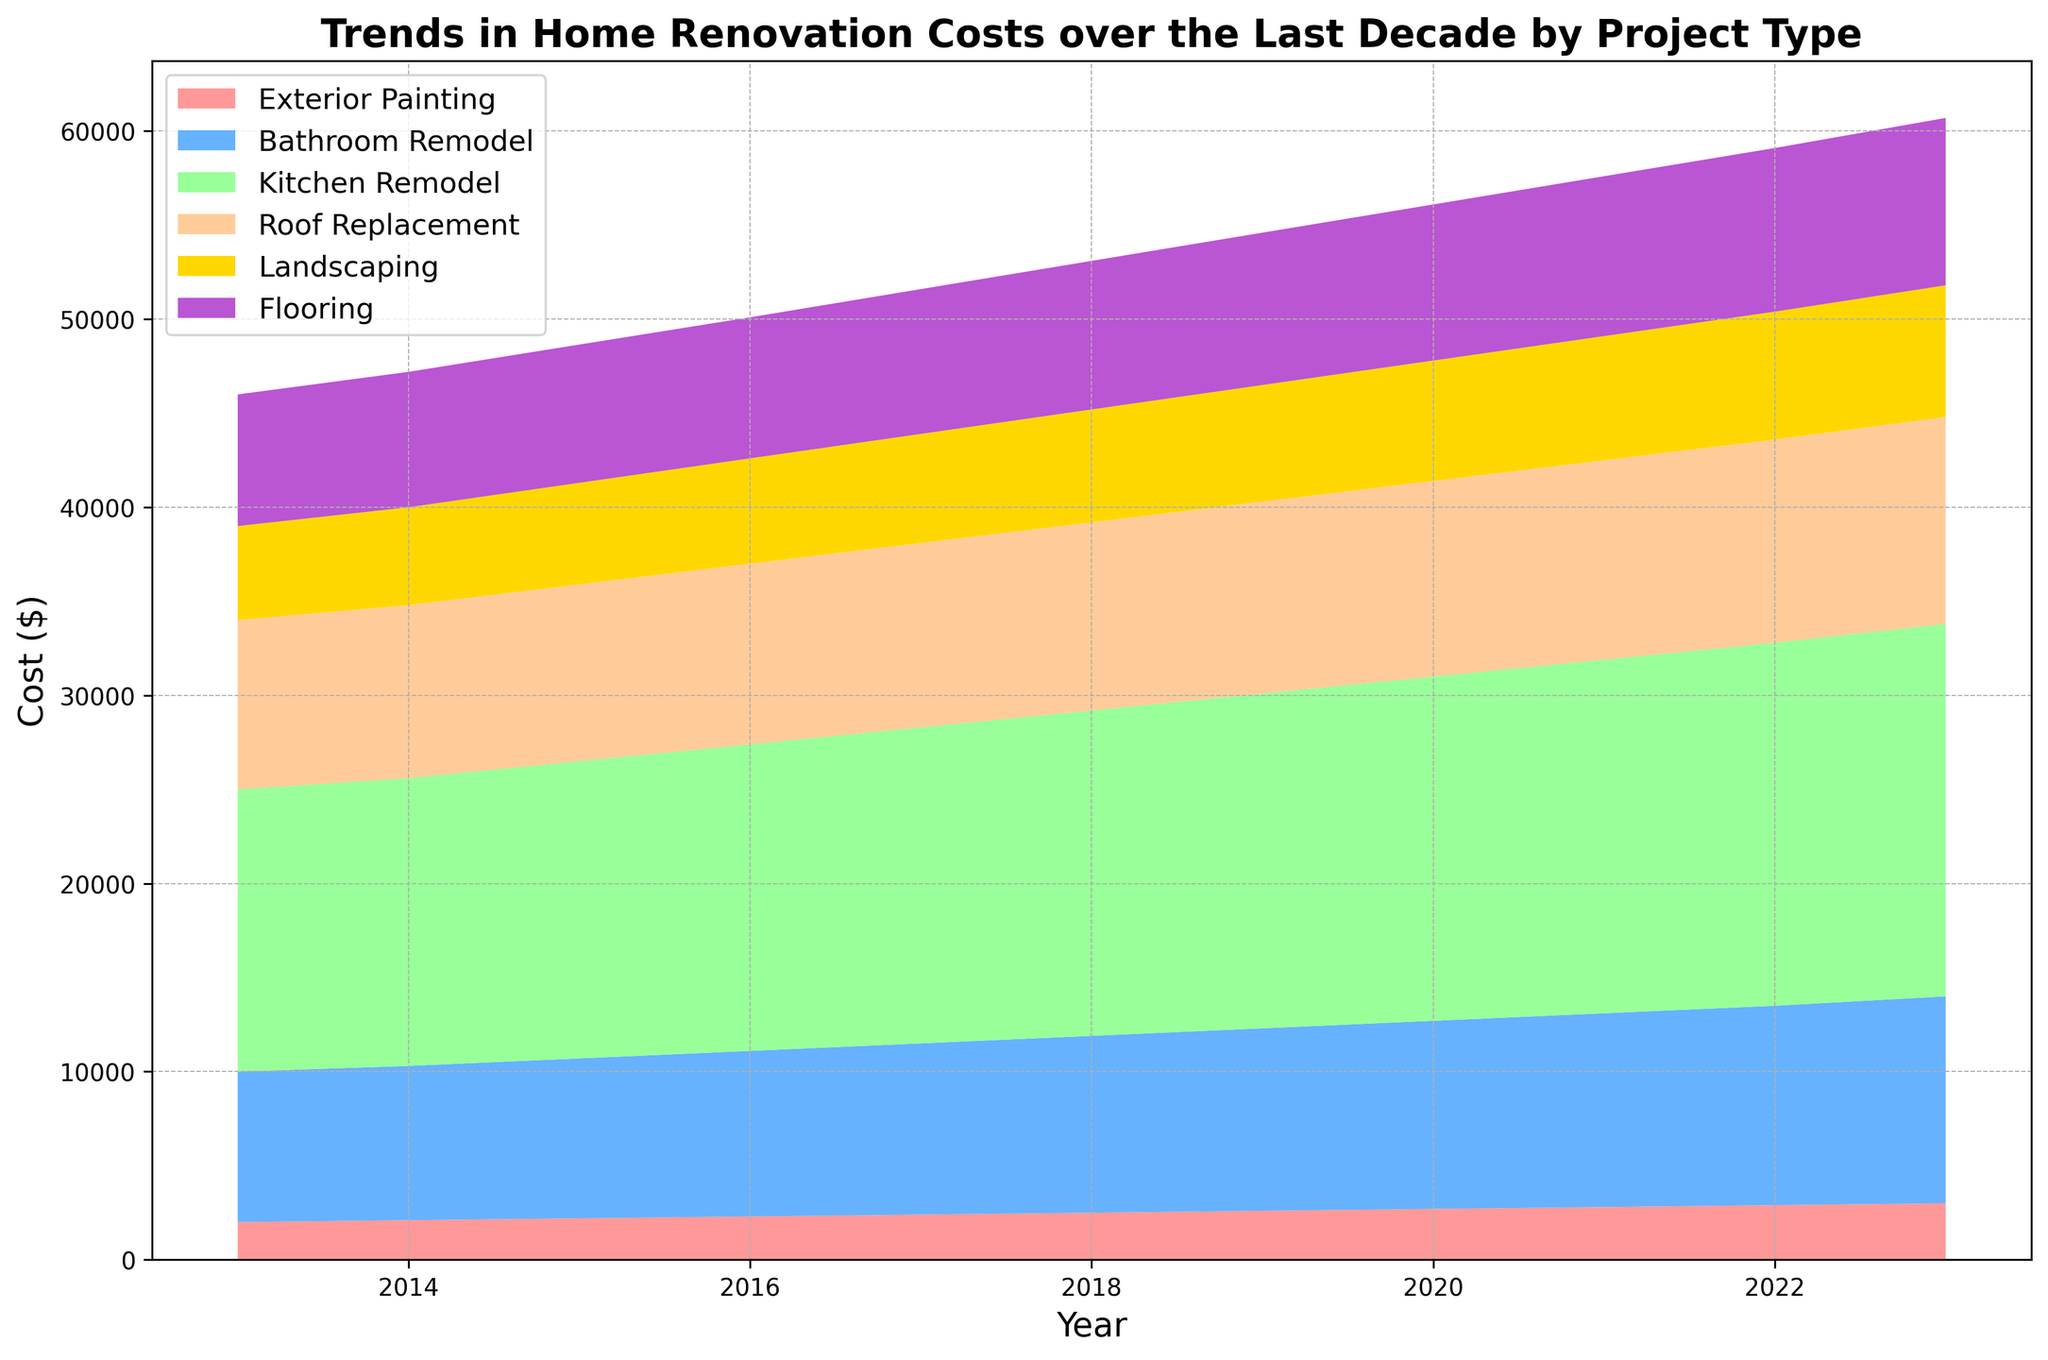What trend do you observe in the cost of exterior painting over the decade? The chart shows a steadily increasing trend in the cost of exterior painting from 2013 to 2023.
Answer: Increasing trend Which project type had the highest cost in 2023? In 2023, the highest cost is represented by the tallest area segment in the stack, which corresponds to the kitchen remodel.
Answer: Kitchen remodel How does the cost of a bathroom remodel compare to a roof replacement in 2020? In 2020, the height of the area segment for bathroom remodel is slightly lower than the segment for roof replacement, indicating its cost was lower.
Answer: Lower What is the total cost of kitchen remodeling from 2013 to 2023? To find the total cost, sum all kitchen remodel costs from 2013 to 2023: 15000 + 15300 + 15800 + 16300 + 16800 + 17300 + 17800 + 18300 + 18800 + 19300 + 19800 = 183400.
Answer: $183,400 By how much did the cost of flooring increase from 2013 to 2023? The cost of flooring in 2013 was $7000, and in 2023 it was $8900. The difference is 8900 - 7000 = 1900.
Answer: $1900 Which renovation project type showed the most significant increase over the decade? The project with the most substantial increase can be identified by comparing the visual height difference from 2013 to 2023. The kitchen remodel shows the largest increase.
Answer: Kitchen remodel What is the average cost of landscaping from 2018 to 2023? Add the landscaping costs from 2018 to 2023 and divide by the number of years: (6000 + 6200 + 6400 + 6600 + 6800 + 7000) / 6 = 6500.
Answer: $6500 Was there any year when the cost of bathroom remodel was equal to the cost of roof replacement? By examining the chart, there is no year where the heights of the segments for bathroom remodel and roof replacement are the same.
Answer: No In which year did the cost of exterior painting experience the highest annual increase? By inspecting the differences in heights year-over-year for exterior painting, the largest increase is between 2022 and 2023.
Answer: Between 2022 and 2023 